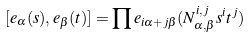Convert formula to latex. <formula><loc_0><loc_0><loc_500><loc_500>[ e _ { \alpha } ( s ) , e _ { \beta } ( t ) ] = \prod e _ { i \alpha + j \beta } ( N _ { \alpha , \beta } ^ { i , j } s ^ { i } t ^ { j } )</formula> 